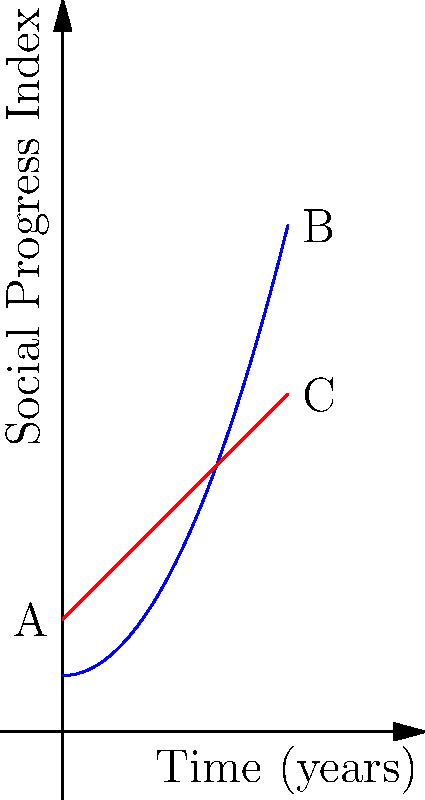The graph shows the impact of feminist legislation on social progress over time. The blue curve represents the cumulative effect of feminist policies, while the red line represents baseline social progress without specific feminist interventions. Calculate the total additional impact of feminist legislation over the 4-year period, represented by the area between the two curves.

Given:
- Blue curve (feminist impact): $f(x) = 0.5x^2 + 1$
- Red line (baseline progress): $g(x) = x + 2$
- Time period: 0 to 4 years

Use integral calculus to find the area between the curves. To find the area between the two curves, we need to:

1. Identify the upper and lower functions:
   Upper function: $f(x) = 0.5x^2 + 1$
   Lower function: $g(x) = x + 2$

2. Set up the integral to calculate the area:
   Area = $\int_0^4 [f(x) - g(x)] dx$

3. Substitute the functions:
   Area = $\int_0^4 [(0.5x^2 + 1) - (x + 2)] dx$

4. Simplify the integrand:
   Area = $\int_0^4 (0.5x^2 - x - 1) dx$

5. Integrate:
   Area = $[\frac{1}{6}x^3 - \frac{1}{2}x^2 - x]_0^4$

6. Evaluate the integral:
   Area = $[(\frac{1}{6} \cdot 64 - \frac{1}{2} \cdot 16 - 4) - (0 - 0 - 0)]$
        = $[\frac{32}{3} - 8 - 4]$
        = $\frac{32}{3} - 12$
        = $\frac{32 - 36}{3}$
        = $-\frac{4}{3}$

7. Take the absolute value (since area is always positive):
   Area = $|\frac{4}{3}| = \frac{4}{3}$

The total additional impact of feminist legislation over the 4-year period is $\frac{4}{3}$ units on the Social Progress Index.
Answer: $\frac{4}{3}$ units 